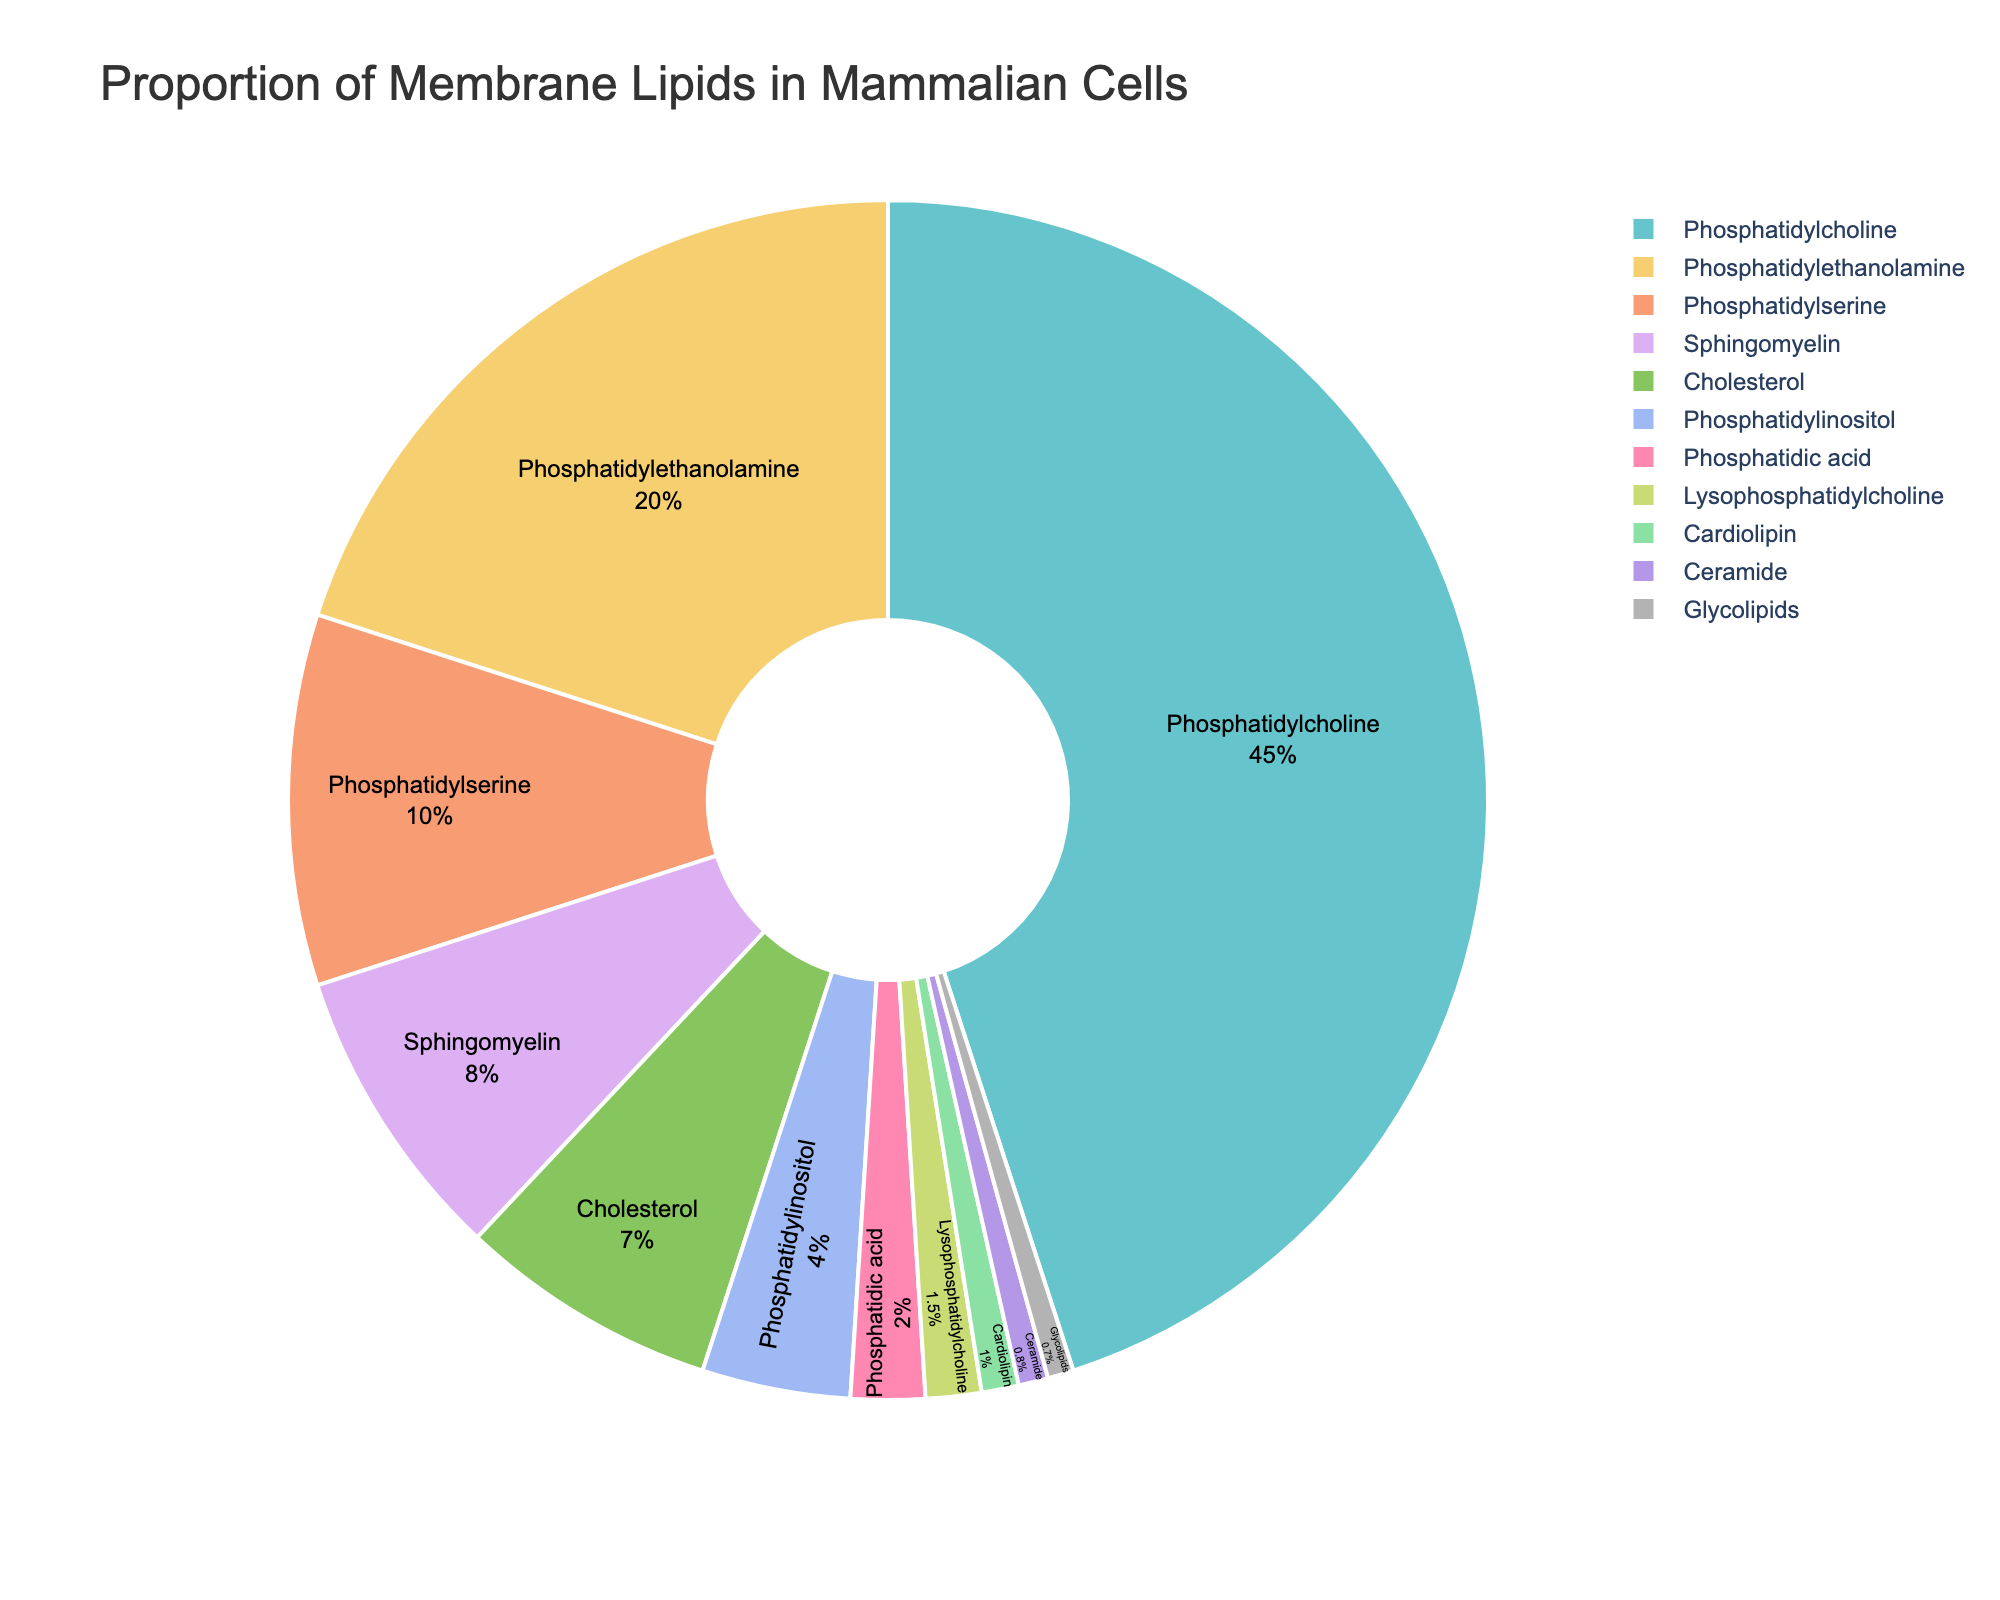what is the proportion of Phosphatidylcholine in the cell membrane? The pie chart shows that Phosphatidylcholine occupies 45% of the mammalian cell membrane lipids.
Answer: 45% Which lipid has the second highest proportion in the cell membrane? From the pie chart, Phosphatidylethanolamine has the second highest proportion at 20%.
Answer: Phosphatidylethanolamine What is the total combined percentage of Phosphatidic acid, Ceramide, and Glycolipids? Adding the percentages of Phosphatidic acid (2%), Ceramide (0.8%), and Glycolipids (0.7%) yields a total combined percentage. 2 + 0.8 + 0.7 = 3.5%
Answer: 3.5% Which lipid makes up a smaller proportion, lysophosphatidylcholine or cholesterol? Lysophosphatidylcholine has 1.5%, while Cholesterol has 7%, making Lysophosphatidylcholine the smaller proportion.
Answer: lysophosphatidylcholine Are Phosphatidylethanolamine and Phosphatidylserine together greater than the sum of Sphingomyelin and Cholesterol? Adding Phosphatidylethanolamine (20%) and Phosphatidylserine (10%) gives 30%. Adding Sphingomyelin (8%) and Cholesterol (7%) gives 15%. 30% is greater than 15%.
Answer: Yes How does the proportion of Cardiolipin compare to Ceramide? The pie chart shows Cardiolipin at 1% and Ceramide at 0.8%.
Answer: Cardiolipin has a larger proportion Which lipid categories together constitute exactly 25% of the cell membrane lipids? Summing up Phosphatidylserine (10%), Sphingomyelin (8%), and Cholesterol (7%) equals exactly 25%.
Answer: Phosphatidylserine, Sphingomyelin, and Cholesterol What visual attribute helps identify the lipid with the smallest proportion? The smallest segment in the pie chart represents Glycolipids at 0.7%. Visually, it is the smallest slice.
Answer: Glycolipids What is the visual difference between the largest and smallest lipid proportion segments? The largest segment (Phosphatidylcholine at 45%) is much larger visually than the smallest segment (Glycolipids at 0.7%), which is barely visible.
Answer: The largest segment is significantly larger than the smallest 